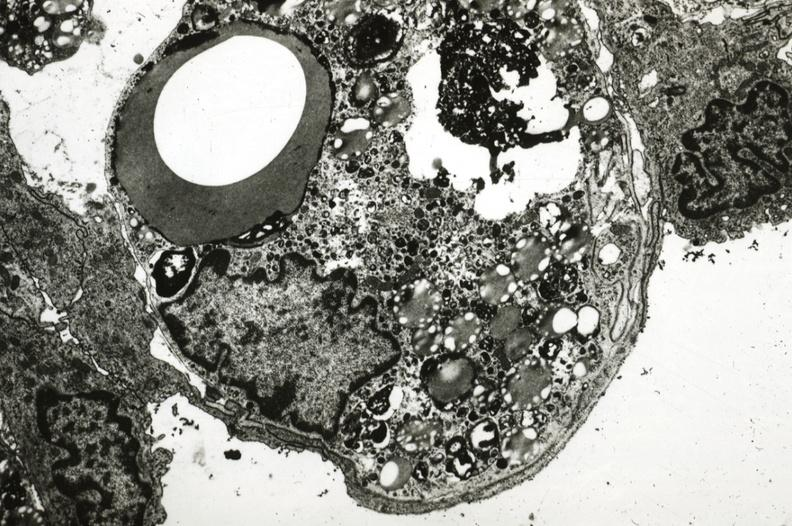s atherosclerosis present?
Answer the question using a single word or phrase. Yes 